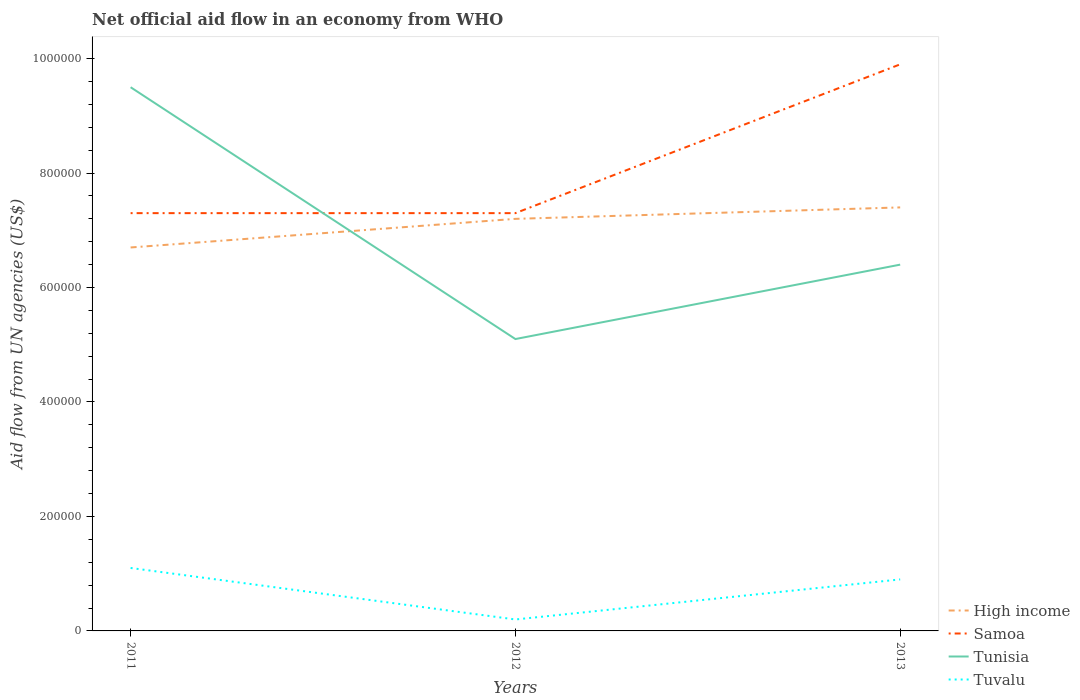Does the line corresponding to Tunisia intersect with the line corresponding to Tuvalu?
Offer a very short reply. No. Is the number of lines equal to the number of legend labels?
Your answer should be compact. Yes. Across all years, what is the maximum net official aid flow in Samoa?
Ensure brevity in your answer.  7.30e+05. What is the total net official aid flow in High income in the graph?
Keep it short and to the point. -7.00e+04. What is the difference between the highest and the second highest net official aid flow in Tunisia?
Make the answer very short. 4.40e+05. What is the difference between the highest and the lowest net official aid flow in Samoa?
Your response must be concise. 1. Is the net official aid flow in Tuvalu strictly greater than the net official aid flow in Tunisia over the years?
Make the answer very short. Yes. How many lines are there?
Provide a short and direct response. 4. How many years are there in the graph?
Provide a short and direct response. 3. What is the difference between two consecutive major ticks on the Y-axis?
Keep it short and to the point. 2.00e+05. Are the values on the major ticks of Y-axis written in scientific E-notation?
Ensure brevity in your answer.  No. Does the graph contain any zero values?
Make the answer very short. No. How are the legend labels stacked?
Keep it short and to the point. Vertical. What is the title of the graph?
Keep it short and to the point. Net official aid flow in an economy from WHO. Does "Liechtenstein" appear as one of the legend labels in the graph?
Give a very brief answer. No. What is the label or title of the X-axis?
Keep it short and to the point. Years. What is the label or title of the Y-axis?
Your answer should be compact. Aid flow from UN agencies (US$). What is the Aid flow from UN agencies (US$) of High income in 2011?
Offer a terse response. 6.70e+05. What is the Aid flow from UN agencies (US$) in Samoa in 2011?
Give a very brief answer. 7.30e+05. What is the Aid flow from UN agencies (US$) in Tunisia in 2011?
Your response must be concise. 9.50e+05. What is the Aid flow from UN agencies (US$) of Tuvalu in 2011?
Your response must be concise. 1.10e+05. What is the Aid flow from UN agencies (US$) of High income in 2012?
Offer a terse response. 7.20e+05. What is the Aid flow from UN agencies (US$) in Samoa in 2012?
Your response must be concise. 7.30e+05. What is the Aid flow from UN agencies (US$) in Tunisia in 2012?
Offer a terse response. 5.10e+05. What is the Aid flow from UN agencies (US$) in High income in 2013?
Provide a succinct answer. 7.40e+05. What is the Aid flow from UN agencies (US$) of Samoa in 2013?
Give a very brief answer. 9.90e+05. What is the Aid flow from UN agencies (US$) in Tunisia in 2013?
Provide a succinct answer. 6.40e+05. Across all years, what is the maximum Aid flow from UN agencies (US$) of High income?
Offer a very short reply. 7.40e+05. Across all years, what is the maximum Aid flow from UN agencies (US$) in Samoa?
Make the answer very short. 9.90e+05. Across all years, what is the maximum Aid flow from UN agencies (US$) of Tunisia?
Offer a terse response. 9.50e+05. Across all years, what is the minimum Aid flow from UN agencies (US$) of High income?
Offer a very short reply. 6.70e+05. Across all years, what is the minimum Aid flow from UN agencies (US$) in Samoa?
Provide a succinct answer. 7.30e+05. Across all years, what is the minimum Aid flow from UN agencies (US$) in Tunisia?
Ensure brevity in your answer.  5.10e+05. Across all years, what is the minimum Aid flow from UN agencies (US$) of Tuvalu?
Provide a short and direct response. 2.00e+04. What is the total Aid flow from UN agencies (US$) of High income in the graph?
Provide a succinct answer. 2.13e+06. What is the total Aid flow from UN agencies (US$) of Samoa in the graph?
Offer a terse response. 2.45e+06. What is the total Aid flow from UN agencies (US$) in Tunisia in the graph?
Offer a terse response. 2.10e+06. What is the total Aid flow from UN agencies (US$) of Tuvalu in the graph?
Offer a very short reply. 2.20e+05. What is the difference between the Aid flow from UN agencies (US$) of High income in 2011 and that in 2013?
Provide a succinct answer. -7.00e+04. What is the difference between the Aid flow from UN agencies (US$) in Samoa in 2011 and that in 2013?
Your answer should be compact. -2.60e+05. What is the difference between the Aid flow from UN agencies (US$) of Tunisia in 2011 and that in 2013?
Keep it short and to the point. 3.10e+05. What is the difference between the Aid flow from UN agencies (US$) in Tunisia in 2012 and that in 2013?
Offer a terse response. -1.30e+05. What is the difference between the Aid flow from UN agencies (US$) in Tuvalu in 2012 and that in 2013?
Provide a succinct answer. -7.00e+04. What is the difference between the Aid flow from UN agencies (US$) in High income in 2011 and the Aid flow from UN agencies (US$) in Samoa in 2012?
Provide a succinct answer. -6.00e+04. What is the difference between the Aid flow from UN agencies (US$) of High income in 2011 and the Aid flow from UN agencies (US$) of Tuvalu in 2012?
Your answer should be compact. 6.50e+05. What is the difference between the Aid flow from UN agencies (US$) of Samoa in 2011 and the Aid flow from UN agencies (US$) of Tuvalu in 2012?
Provide a short and direct response. 7.10e+05. What is the difference between the Aid flow from UN agencies (US$) in Tunisia in 2011 and the Aid flow from UN agencies (US$) in Tuvalu in 2012?
Your answer should be very brief. 9.30e+05. What is the difference between the Aid flow from UN agencies (US$) of High income in 2011 and the Aid flow from UN agencies (US$) of Samoa in 2013?
Offer a terse response. -3.20e+05. What is the difference between the Aid flow from UN agencies (US$) in High income in 2011 and the Aid flow from UN agencies (US$) in Tuvalu in 2013?
Your answer should be very brief. 5.80e+05. What is the difference between the Aid flow from UN agencies (US$) of Samoa in 2011 and the Aid flow from UN agencies (US$) of Tunisia in 2013?
Provide a short and direct response. 9.00e+04. What is the difference between the Aid flow from UN agencies (US$) in Samoa in 2011 and the Aid flow from UN agencies (US$) in Tuvalu in 2013?
Make the answer very short. 6.40e+05. What is the difference between the Aid flow from UN agencies (US$) of Tunisia in 2011 and the Aid flow from UN agencies (US$) of Tuvalu in 2013?
Provide a short and direct response. 8.60e+05. What is the difference between the Aid flow from UN agencies (US$) in High income in 2012 and the Aid flow from UN agencies (US$) in Samoa in 2013?
Your response must be concise. -2.70e+05. What is the difference between the Aid flow from UN agencies (US$) in High income in 2012 and the Aid flow from UN agencies (US$) in Tunisia in 2013?
Your response must be concise. 8.00e+04. What is the difference between the Aid flow from UN agencies (US$) of High income in 2012 and the Aid flow from UN agencies (US$) of Tuvalu in 2013?
Your response must be concise. 6.30e+05. What is the difference between the Aid flow from UN agencies (US$) of Samoa in 2012 and the Aid flow from UN agencies (US$) of Tuvalu in 2013?
Keep it short and to the point. 6.40e+05. What is the average Aid flow from UN agencies (US$) of High income per year?
Offer a very short reply. 7.10e+05. What is the average Aid flow from UN agencies (US$) in Samoa per year?
Make the answer very short. 8.17e+05. What is the average Aid flow from UN agencies (US$) of Tuvalu per year?
Offer a very short reply. 7.33e+04. In the year 2011, what is the difference between the Aid flow from UN agencies (US$) of High income and Aid flow from UN agencies (US$) of Tunisia?
Your answer should be very brief. -2.80e+05. In the year 2011, what is the difference between the Aid flow from UN agencies (US$) in High income and Aid flow from UN agencies (US$) in Tuvalu?
Offer a very short reply. 5.60e+05. In the year 2011, what is the difference between the Aid flow from UN agencies (US$) of Samoa and Aid flow from UN agencies (US$) of Tuvalu?
Offer a very short reply. 6.20e+05. In the year 2011, what is the difference between the Aid flow from UN agencies (US$) of Tunisia and Aid flow from UN agencies (US$) of Tuvalu?
Offer a very short reply. 8.40e+05. In the year 2012, what is the difference between the Aid flow from UN agencies (US$) in High income and Aid flow from UN agencies (US$) in Tuvalu?
Provide a short and direct response. 7.00e+05. In the year 2012, what is the difference between the Aid flow from UN agencies (US$) of Samoa and Aid flow from UN agencies (US$) of Tunisia?
Offer a very short reply. 2.20e+05. In the year 2012, what is the difference between the Aid flow from UN agencies (US$) in Samoa and Aid flow from UN agencies (US$) in Tuvalu?
Make the answer very short. 7.10e+05. In the year 2012, what is the difference between the Aid flow from UN agencies (US$) of Tunisia and Aid flow from UN agencies (US$) of Tuvalu?
Offer a terse response. 4.90e+05. In the year 2013, what is the difference between the Aid flow from UN agencies (US$) of High income and Aid flow from UN agencies (US$) of Tunisia?
Your answer should be compact. 1.00e+05. In the year 2013, what is the difference between the Aid flow from UN agencies (US$) of High income and Aid flow from UN agencies (US$) of Tuvalu?
Your answer should be very brief. 6.50e+05. In the year 2013, what is the difference between the Aid flow from UN agencies (US$) of Samoa and Aid flow from UN agencies (US$) of Tunisia?
Your answer should be very brief. 3.50e+05. In the year 2013, what is the difference between the Aid flow from UN agencies (US$) of Samoa and Aid flow from UN agencies (US$) of Tuvalu?
Keep it short and to the point. 9.00e+05. What is the ratio of the Aid flow from UN agencies (US$) of High income in 2011 to that in 2012?
Provide a succinct answer. 0.93. What is the ratio of the Aid flow from UN agencies (US$) in Tunisia in 2011 to that in 2012?
Your answer should be compact. 1.86. What is the ratio of the Aid flow from UN agencies (US$) of High income in 2011 to that in 2013?
Ensure brevity in your answer.  0.91. What is the ratio of the Aid flow from UN agencies (US$) of Samoa in 2011 to that in 2013?
Ensure brevity in your answer.  0.74. What is the ratio of the Aid flow from UN agencies (US$) in Tunisia in 2011 to that in 2013?
Keep it short and to the point. 1.48. What is the ratio of the Aid flow from UN agencies (US$) in Tuvalu in 2011 to that in 2013?
Make the answer very short. 1.22. What is the ratio of the Aid flow from UN agencies (US$) of Samoa in 2012 to that in 2013?
Your answer should be very brief. 0.74. What is the ratio of the Aid flow from UN agencies (US$) in Tunisia in 2012 to that in 2013?
Your response must be concise. 0.8. What is the ratio of the Aid flow from UN agencies (US$) of Tuvalu in 2012 to that in 2013?
Provide a succinct answer. 0.22. What is the difference between the highest and the second highest Aid flow from UN agencies (US$) in Samoa?
Make the answer very short. 2.60e+05. What is the difference between the highest and the lowest Aid flow from UN agencies (US$) of High income?
Provide a succinct answer. 7.00e+04. 